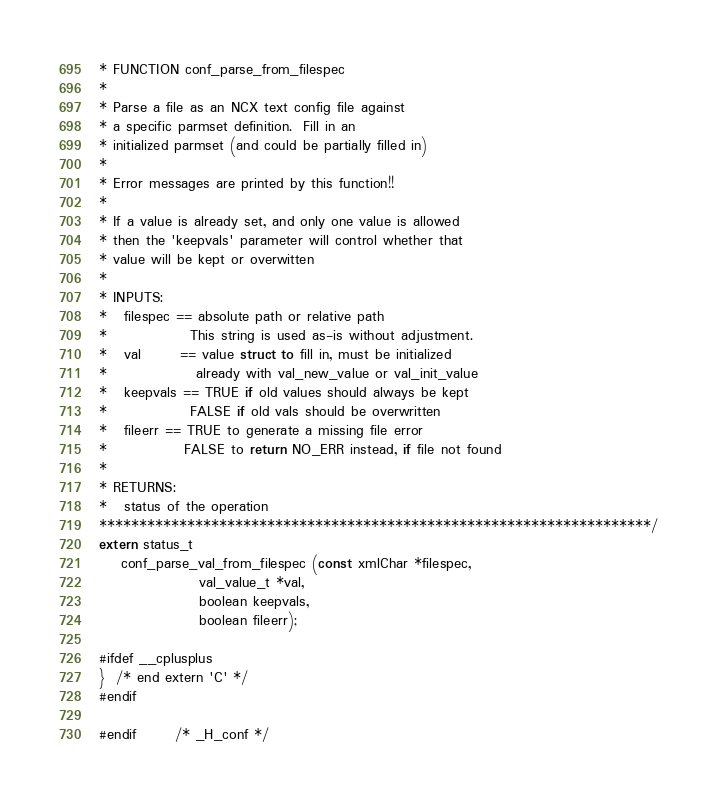Convert code to text. <code><loc_0><loc_0><loc_500><loc_500><_C_>* FUNCTION conf_parse_from_filespec
* 
* Parse a file as an NCX text config file against
* a specific parmset definition.  Fill in an
* initialized parmset (and could be partially filled in)
*
* Error messages are printed by this function!!
*
* If a value is already set, and only one value is allowed
* then the 'keepvals' parameter will control whether that
* value will be kept or overwitten
*
* INPUTS:
*   filespec == absolute path or relative path
*               This string is used as-is without adjustment.
*   val       == value struct to fill in, must be initialized
*                already with val_new_value or val_init_value
*   keepvals == TRUE if old values should always be kept
*               FALSE if old vals should be overwritten
*   fileerr == TRUE to generate a missing file error
*              FALSE to return NO_ERR instead, if file not found
*
* RETURNS:
*   status of the operation
*********************************************************************/
extern status_t 
    conf_parse_val_from_filespec (const xmlChar *filespec,
				  val_value_t *val,
				  boolean keepvals,
				  boolean fileerr);

#ifdef __cplusplus
}  /* end extern 'C' */
#endif

#endif	    /* _H_conf */
</code> 